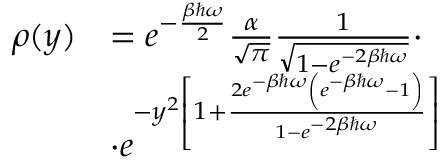<formula> <loc_0><loc_0><loc_500><loc_500>\begin{array} { r l } { \rho ( y ) } & { = e ^ { - \frac { \beta \hbar { \omega } } { 2 } } \frac { \alpha } { \sqrt { \pi } } \frac { 1 } { \sqrt { 1 - e ^ { - 2 \beta \hbar { \omega } } } } \cdot } \\ & { \cdot e ^ { - y ^ { 2 } \left [ 1 + \frac { 2 e ^ { - \beta \hbar { \omega } } \left ( e ^ { - \beta \hbar { \omega } } - 1 \right ) } { 1 - e ^ { - 2 \beta \hbar { \omega } } } \right ] } } \end{array}</formula> 